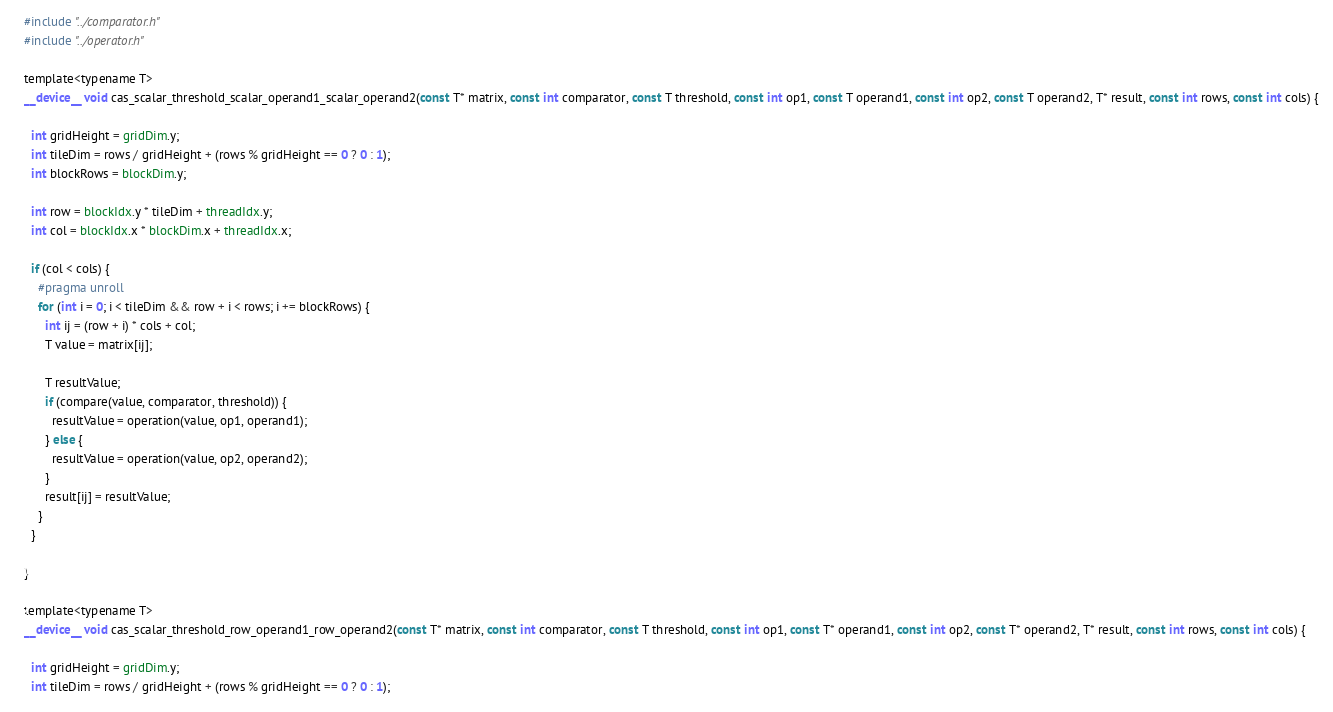<code> <loc_0><loc_0><loc_500><loc_500><_Cuda_>#include "../comparator.h"
#include "../operator.h"

template<typename T>
__device__ void cas_scalar_threshold_scalar_operand1_scalar_operand2(const T* matrix, const int comparator, const T threshold, const int op1, const T operand1, const int op2, const T operand2, T* result, const int rows, const int cols) {

  int gridHeight = gridDim.y;
  int tileDim = rows / gridHeight + (rows % gridHeight == 0 ? 0 : 1);
  int blockRows = blockDim.y;

  int row = blockIdx.y * tileDim + threadIdx.y;
  int col = blockIdx.x * blockDim.x + threadIdx.x;

  if (col < cols) {
    #pragma unroll
    for (int i = 0; i < tileDim && row + i < rows; i += blockRows) {
      int ij = (row + i) * cols + col;
      T value = matrix[ij];

      T resultValue;
      if (compare(value, comparator, threshold)) {
        resultValue = operation(value, op1, operand1);
      } else {
        resultValue = operation(value, op2, operand2);
      }
      result[ij] = resultValue;
    }
  }

}

template<typename T>
__device__ void cas_scalar_threshold_row_operand1_row_operand2(const T* matrix, const int comparator, const T threshold, const int op1, const T* operand1, const int op2, const T* operand2, T* result, const int rows, const int cols) {

  int gridHeight = gridDim.y;
  int tileDim = rows / gridHeight + (rows % gridHeight == 0 ? 0 : 1);</code> 